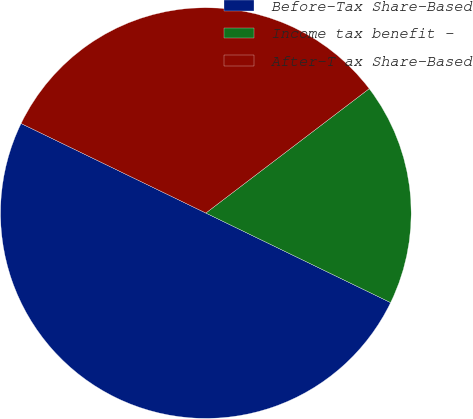Convert chart. <chart><loc_0><loc_0><loc_500><loc_500><pie_chart><fcel>Before-Tax Share-Based<fcel>Income tax benefit -<fcel>After-T ax Share-Based<nl><fcel>50.0%<fcel>17.54%<fcel>32.46%<nl></chart> 